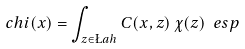Convert formula to latex. <formula><loc_0><loc_0><loc_500><loc_500>c h i ( x ) = \int _ { z \in \L a h } C ( x , z ) \, \chi ( z ) \ e s p</formula> 